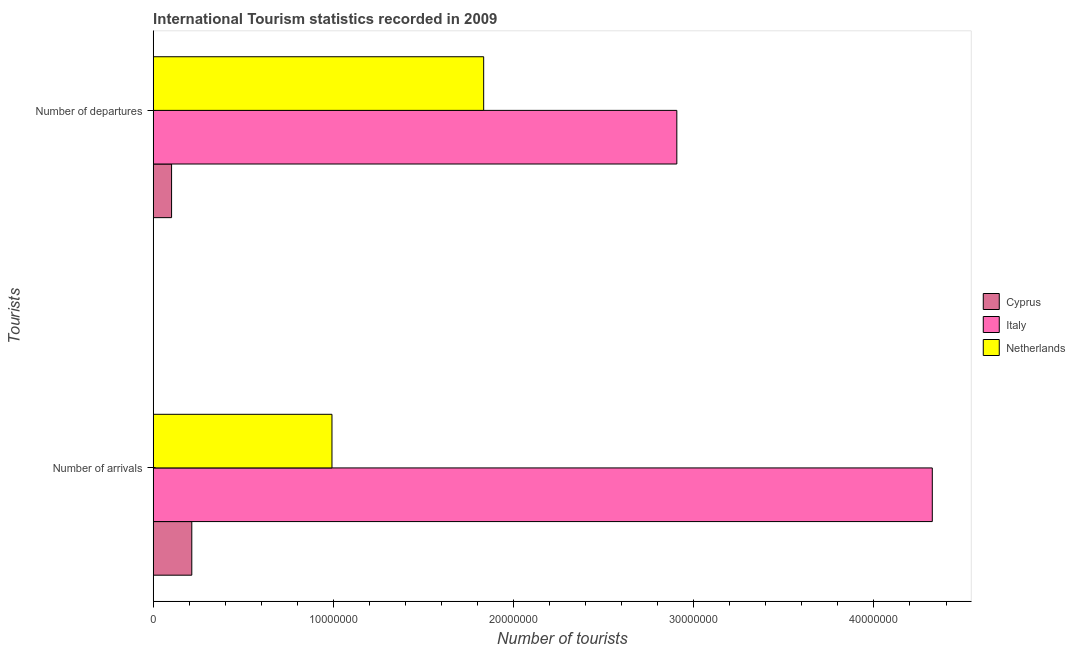How many different coloured bars are there?
Your answer should be compact. 3. How many groups of bars are there?
Your answer should be very brief. 2. Are the number of bars on each tick of the Y-axis equal?
Your answer should be very brief. Yes. How many bars are there on the 1st tick from the bottom?
Give a very brief answer. 3. What is the label of the 2nd group of bars from the top?
Give a very brief answer. Number of arrivals. What is the number of tourist departures in Italy?
Ensure brevity in your answer.  2.91e+07. Across all countries, what is the maximum number of tourist departures?
Offer a very short reply. 2.91e+07. Across all countries, what is the minimum number of tourist arrivals?
Make the answer very short. 2.14e+06. In which country was the number of tourist departures minimum?
Your answer should be compact. Cyprus. What is the total number of tourist arrivals in the graph?
Provide a short and direct response. 5.53e+07. What is the difference between the number of tourist departures in Italy and that in Netherlands?
Your response must be concise. 1.07e+07. What is the difference between the number of tourist departures in Netherlands and the number of tourist arrivals in Cyprus?
Your answer should be very brief. 1.62e+07. What is the average number of tourist departures per country?
Ensure brevity in your answer.  1.61e+07. What is the difference between the number of tourist arrivals and number of tourist departures in Netherlands?
Keep it short and to the point. -8.42e+06. In how many countries, is the number of tourist departures greater than 8000000 ?
Provide a short and direct response. 2. What is the ratio of the number of tourist arrivals in Cyprus to that in Italy?
Make the answer very short. 0.05. What does the 1st bar from the bottom in Number of departures represents?
Make the answer very short. Cyprus. What is the difference between two consecutive major ticks on the X-axis?
Give a very brief answer. 1.00e+07. Does the graph contain any zero values?
Your answer should be very brief. No. Does the graph contain grids?
Offer a terse response. No. How many legend labels are there?
Provide a short and direct response. 3. How are the legend labels stacked?
Your response must be concise. Vertical. What is the title of the graph?
Ensure brevity in your answer.  International Tourism statistics recorded in 2009. What is the label or title of the X-axis?
Keep it short and to the point. Number of tourists. What is the label or title of the Y-axis?
Keep it short and to the point. Tourists. What is the Number of tourists of Cyprus in Number of arrivals?
Offer a terse response. 2.14e+06. What is the Number of tourists in Italy in Number of arrivals?
Offer a terse response. 4.32e+07. What is the Number of tourists in Netherlands in Number of arrivals?
Offer a terse response. 9.92e+06. What is the Number of tourists of Cyprus in Number of departures?
Provide a short and direct response. 1.02e+06. What is the Number of tourists in Italy in Number of departures?
Your answer should be very brief. 2.91e+07. What is the Number of tourists in Netherlands in Number of departures?
Make the answer very short. 1.83e+07. Across all Tourists, what is the maximum Number of tourists in Cyprus?
Your answer should be very brief. 2.14e+06. Across all Tourists, what is the maximum Number of tourists in Italy?
Offer a very short reply. 4.32e+07. Across all Tourists, what is the maximum Number of tourists of Netherlands?
Make the answer very short. 1.83e+07. Across all Tourists, what is the minimum Number of tourists of Cyprus?
Provide a short and direct response. 1.02e+06. Across all Tourists, what is the minimum Number of tourists of Italy?
Offer a terse response. 2.91e+07. Across all Tourists, what is the minimum Number of tourists in Netherlands?
Make the answer very short. 9.92e+06. What is the total Number of tourists of Cyprus in the graph?
Make the answer very short. 3.16e+06. What is the total Number of tourists in Italy in the graph?
Ensure brevity in your answer.  7.23e+07. What is the total Number of tourists in Netherlands in the graph?
Your answer should be very brief. 2.83e+07. What is the difference between the Number of tourists in Cyprus in Number of arrivals and that in Number of departures?
Your answer should be compact. 1.12e+06. What is the difference between the Number of tourists in Italy in Number of arrivals and that in Number of departures?
Your answer should be very brief. 1.42e+07. What is the difference between the Number of tourists in Netherlands in Number of arrivals and that in Number of departures?
Offer a very short reply. -8.42e+06. What is the difference between the Number of tourists in Cyprus in Number of arrivals and the Number of tourists in Italy in Number of departures?
Provide a succinct answer. -2.69e+07. What is the difference between the Number of tourists in Cyprus in Number of arrivals and the Number of tourists in Netherlands in Number of departures?
Ensure brevity in your answer.  -1.62e+07. What is the difference between the Number of tourists of Italy in Number of arrivals and the Number of tourists of Netherlands in Number of departures?
Your answer should be compact. 2.49e+07. What is the average Number of tourists of Cyprus per Tourists?
Offer a terse response. 1.58e+06. What is the average Number of tourists in Italy per Tourists?
Give a very brief answer. 3.61e+07. What is the average Number of tourists of Netherlands per Tourists?
Provide a succinct answer. 1.41e+07. What is the difference between the Number of tourists of Cyprus and Number of tourists of Italy in Number of arrivals?
Your answer should be very brief. -4.11e+07. What is the difference between the Number of tourists of Cyprus and Number of tourists of Netherlands in Number of arrivals?
Make the answer very short. -7.78e+06. What is the difference between the Number of tourists in Italy and Number of tourists in Netherlands in Number of arrivals?
Your response must be concise. 3.33e+07. What is the difference between the Number of tourists in Cyprus and Number of tourists in Italy in Number of departures?
Provide a short and direct response. -2.80e+07. What is the difference between the Number of tourists in Cyprus and Number of tourists in Netherlands in Number of departures?
Give a very brief answer. -1.73e+07. What is the difference between the Number of tourists of Italy and Number of tourists of Netherlands in Number of departures?
Your response must be concise. 1.07e+07. What is the ratio of the Number of tourists of Cyprus in Number of arrivals to that in Number of departures?
Your response must be concise. 2.1. What is the ratio of the Number of tourists of Italy in Number of arrivals to that in Number of departures?
Your answer should be compact. 1.49. What is the ratio of the Number of tourists in Netherlands in Number of arrivals to that in Number of departures?
Keep it short and to the point. 0.54. What is the difference between the highest and the second highest Number of tourists in Cyprus?
Provide a short and direct response. 1.12e+06. What is the difference between the highest and the second highest Number of tourists of Italy?
Give a very brief answer. 1.42e+07. What is the difference between the highest and the second highest Number of tourists in Netherlands?
Provide a succinct answer. 8.42e+06. What is the difference between the highest and the lowest Number of tourists in Cyprus?
Provide a short and direct response. 1.12e+06. What is the difference between the highest and the lowest Number of tourists of Italy?
Offer a terse response. 1.42e+07. What is the difference between the highest and the lowest Number of tourists of Netherlands?
Ensure brevity in your answer.  8.42e+06. 